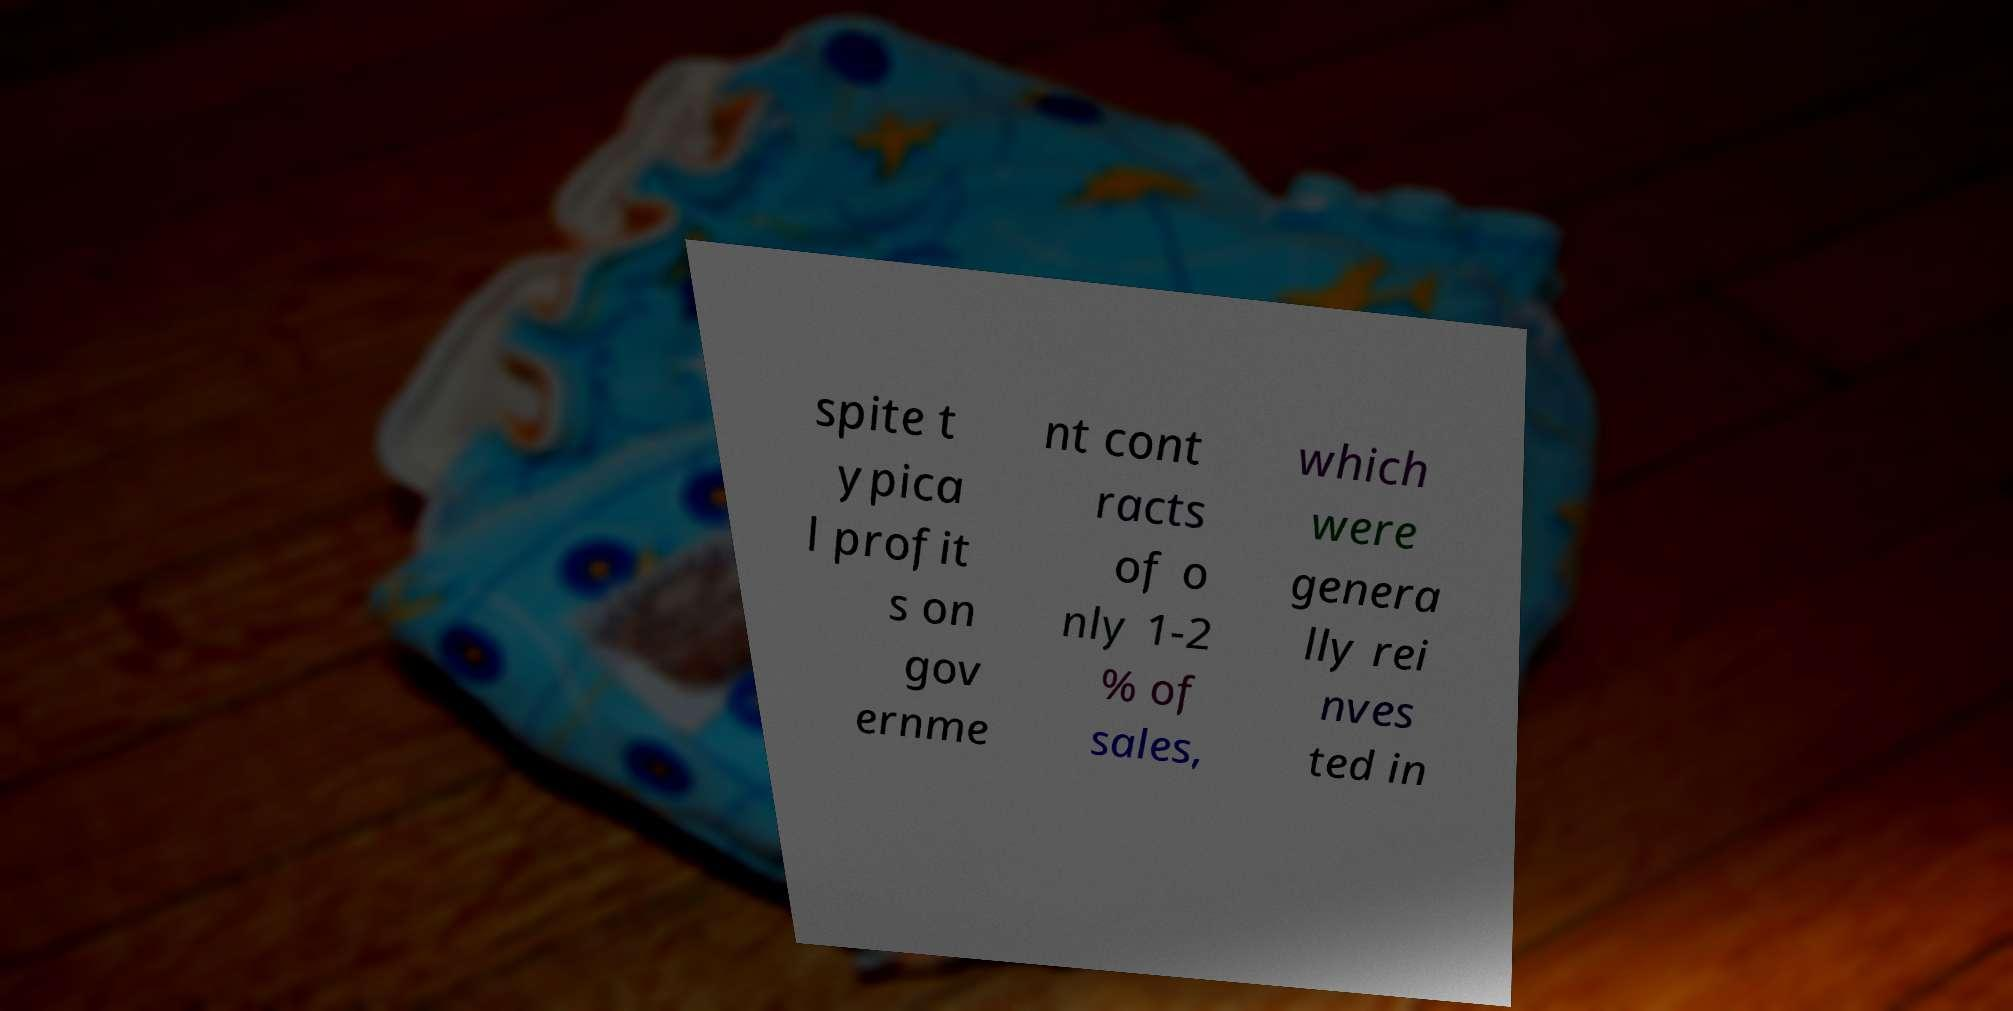Can you accurately transcribe the text from the provided image for me? spite t ypica l profit s on gov ernme nt cont racts of o nly 1-2 % of sales, which were genera lly rei nves ted in 